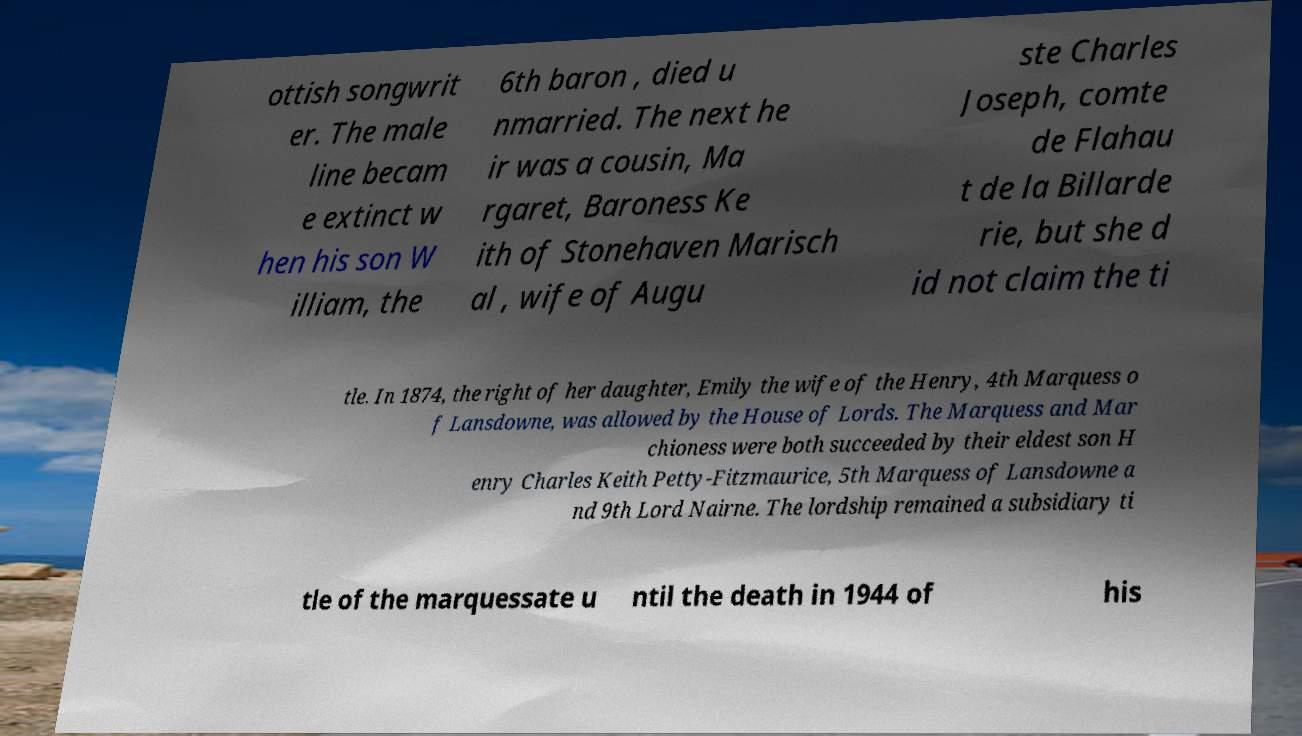What messages or text are displayed in this image? I need them in a readable, typed format. ottish songwrit er. The male line becam e extinct w hen his son W illiam, the 6th baron , died u nmarried. The next he ir was a cousin, Ma rgaret, Baroness Ke ith of Stonehaven Marisch al , wife of Augu ste Charles Joseph, comte de Flahau t de la Billarde rie, but she d id not claim the ti tle. In 1874, the right of her daughter, Emily the wife of the Henry, 4th Marquess o f Lansdowne, was allowed by the House of Lords. The Marquess and Mar chioness were both succeeded by their eldest son H enry Charles Keith Petty-Fitzmaurice, 5th Marquess of Lansdowne a nd 9th Lord Nairne. The lordship remained a subsidiary ti tle of the marquessate u ntil the death in 1944 of his 